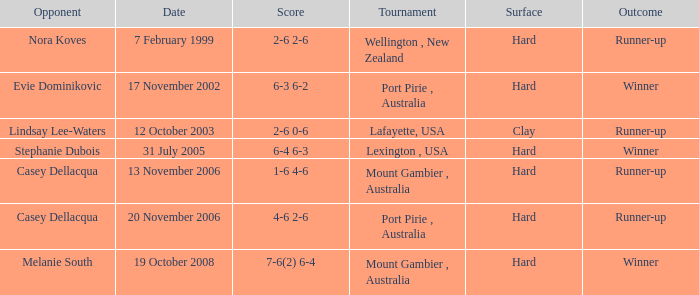When is an Opponent of evie dominikovic? 17 November 2002. 